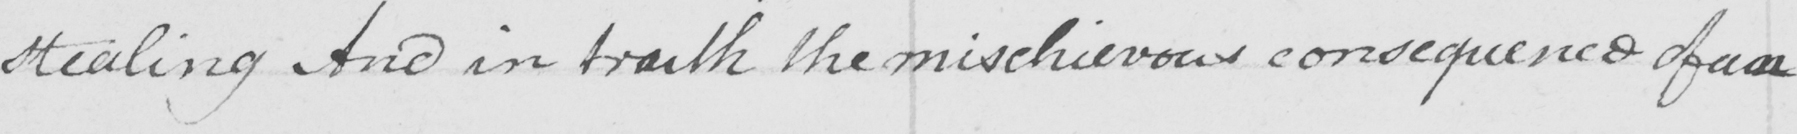What text is written in this handwritten line? stealing And in truth the mischievous consequence of an 